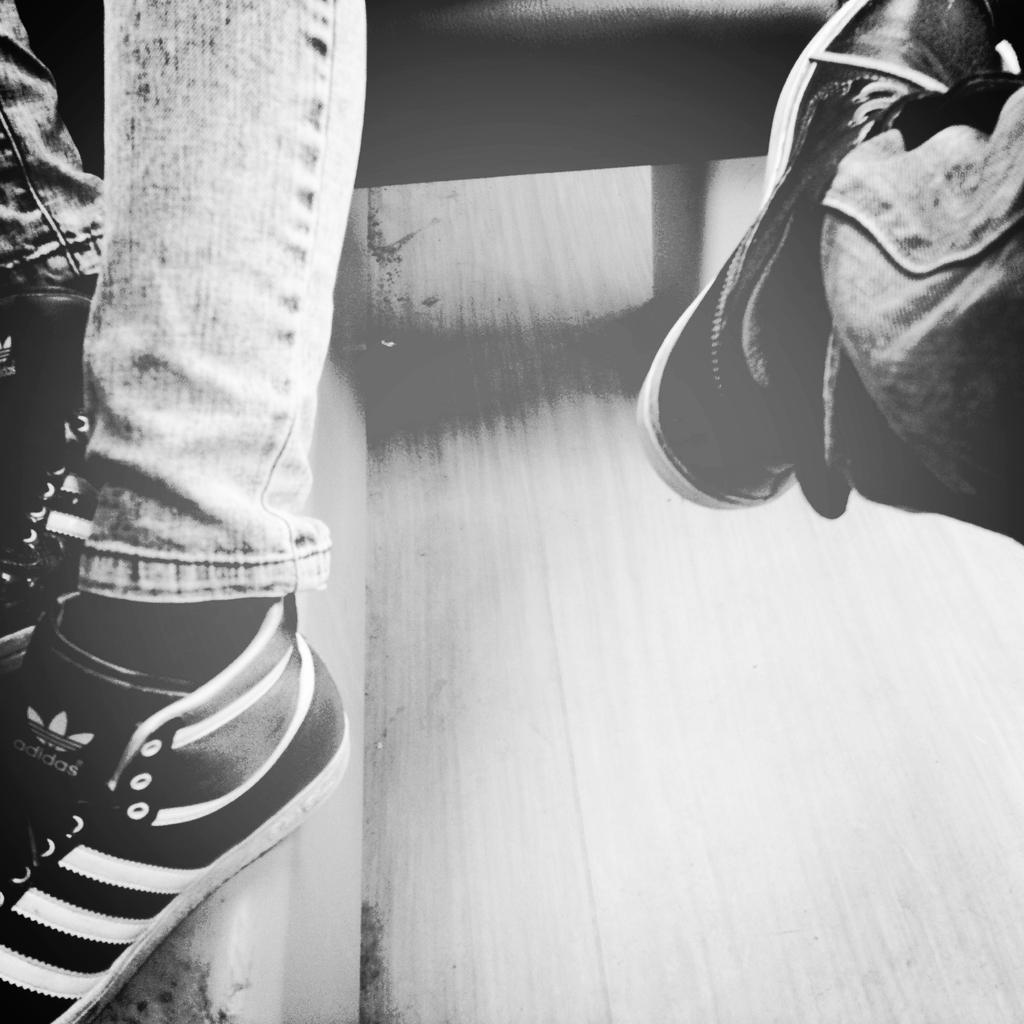What part of a person can be seen in the image? There are legs of a person in the image. What type of footwear is the person wearing? The person is wearing shoes. What type of clothing is the person wearing on their legs? The person is wearing jeans. What color scheme is used in the image? The image is in black and white color. How much debt does the person in the image have? There is no information about the person's debt in the image. What type of expert is the person in the image? There is no indication of the person's expertise in the image. 